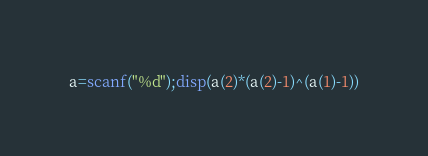Convert code to text. <code><loc_0><loc_0><loc_500><loc_500><_Octave_>a=scanf("%d");disp(a(2)*(a(2)-1)^(a(1)-1))</code> 